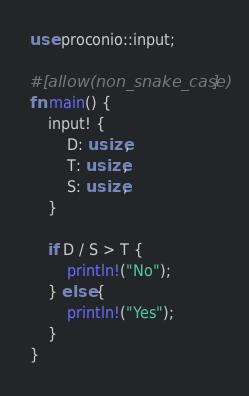Convert code to text. <code><loc_0><loc_0><loc_500><loc_500><_Rust_>use proconio::input;

#[allow(non_snake_case)]
fn main() {
    input! {
        D: usize,
        T: usize,
        S: usize,
    }

    if D / S > T {
        println!("No");
    } else {
        println!("Yes");
    }
}
</code> 